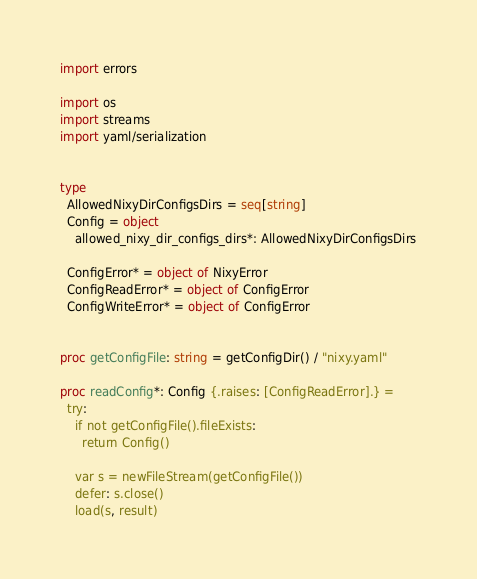Convert code to text. <code><loc_0><loc_0><loc_500><loc_500><_Nim_>import errors

import os
import streams
import yaml/serialization


type
  AllowedNixyDirConfigsDirs = seq[string]
  Config = object
    allowed_nixy_dir_configs_dirs*: AllowedNixyDirConfigsDirs

  ConfigError* = object of NixyError
  ConfigReadError* = object of ConfigError
  ConfigWriteError* = object of ConfigError


proc getConfigFile: string = getConfigDir() / "nixy.yaml"

proc readConfig*: Config {.raises: [ConfigReadError].} =
  try:
    if not getConfigFile().fileExists:
      return Config()

    var s = newFileStream(getConfigFile())
    defer: s.close()
    load(s, result)</code> 